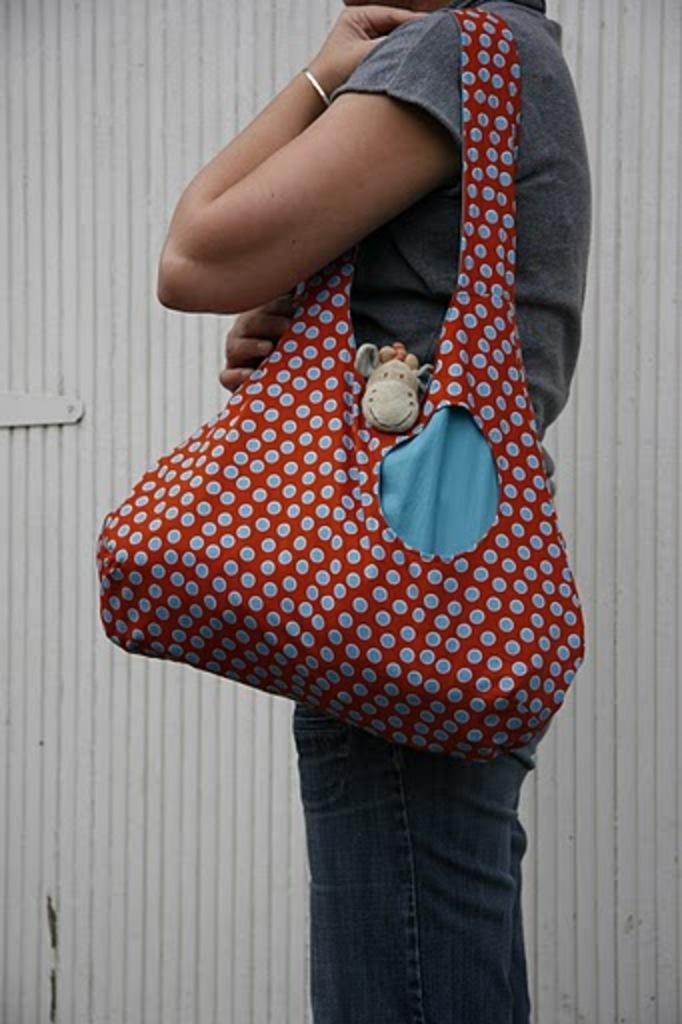Please provide a concise description of this image. there is a person standing wearing a bag. 